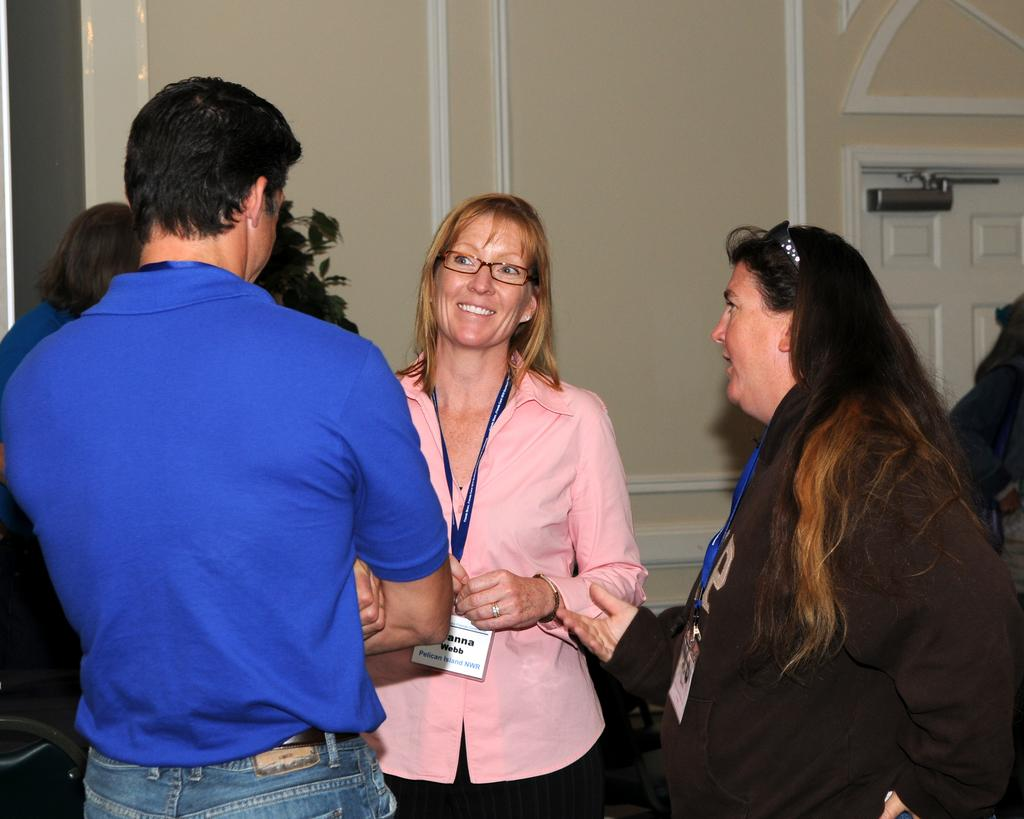What is happening in the image? There are people standing in the image. Can you describe the expression of one of the individuals? There is a woman smiling in the image. What object can be seen in the image that is related to identification or organization? There is a wire tag in the image. What architectural features are visible in the background of the image? There is a door and a wall in the background of the image. What type of vegetation is present in the background of the image? There is a plant in the background of the image. What type of locket is the woman wearing in the image? There is no locket visible on the woman in the image. What type of cloth is draped over the plant in the background? There is no cloth draped over the plant in the background; the plant is visible without any covering. 